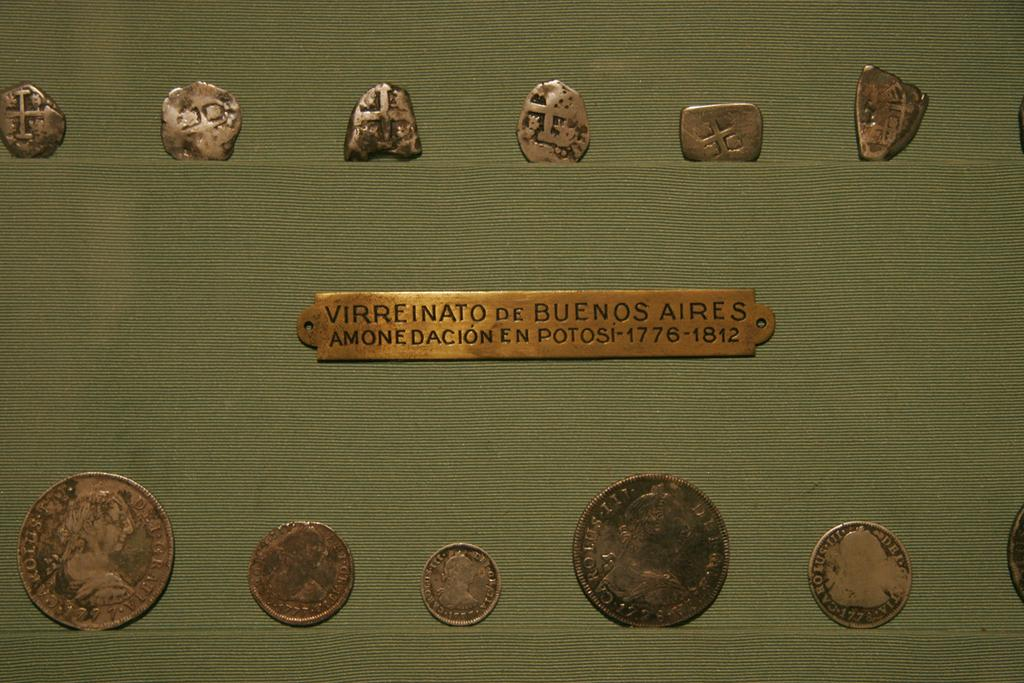<image>
Write a terse but informative summary of the picture. A copper tag that says "Virreinato de BUenos Aires" between some coins. 